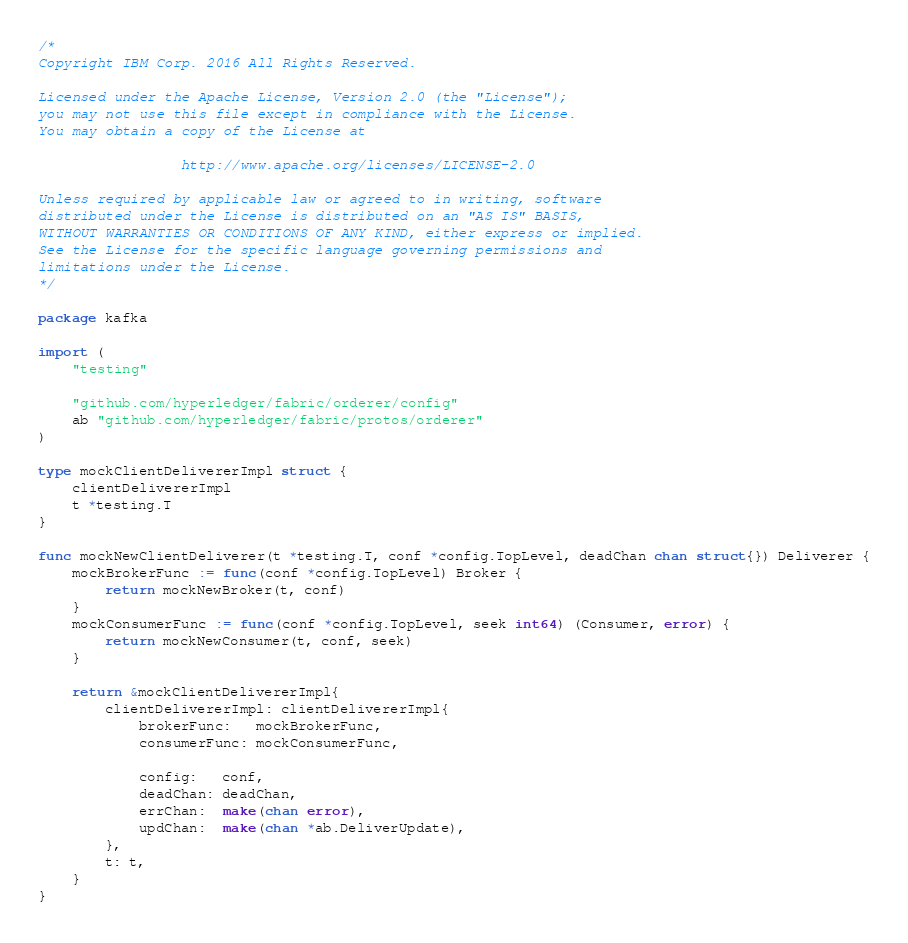Convert code to text. <code><loc_0><loc_0><loc_500><loc_500><_Go_>/*
Copyright IBM Corp. 2016 All Rights Reserved.

Licensed under the Apache License, Version 2.0 (the "License");
you may not use this file except in compliance with the License.
You may obtain a copy of the License at

                 http://www.apache.org/licenses/LICENSE-2.0

Unless required by applicable law or agreed to in writing, software
distributed under the License is distributed on an "AS IS" BASIS,
WITHOUT WARRANTIES OR CONDITIONS OF ANY KIND, either express or implied.
See the License for the specific language governing permissions and
limitations under the License.
*/

package kafka

import (
	"testing"

	"github.com/hyperledger/fabric/orderer/config"
	ab "github.com/hyperledger/fabric/protos/orderer"
)

type mockClientDelivererImpl struct {
	clientDelivererImpl
	t *testing.T
}

func mockNewClientDeliverer(t *testing.T, conf *config.TopLevel, deadChan chan struct{}) Deliverer {
	mockBrokerFunc := func(conf *config.TopLevel) Broker {
		return mockNewBroker(t, conf)
	}
	mockConsumerFunc := func(conf *config.TopLevel, seek int64) (Consumer, error) {
		return mockNewConsumer(t, conf, seek)
	}

	return &mockClientDelivererImpl{
		clientDelivererImpl: clientDelivererImpl{
			brokerFunc:   mockBrokerFunc,
			consumerFunc: mockConsumerFunc,

			config:   conf,
			deadChan: deadChan,
			errChan:  make(chan error),
			updChan:  make(chan *ab.DeliverUpdate),
		},
		t: t,
	}
}
</code> 